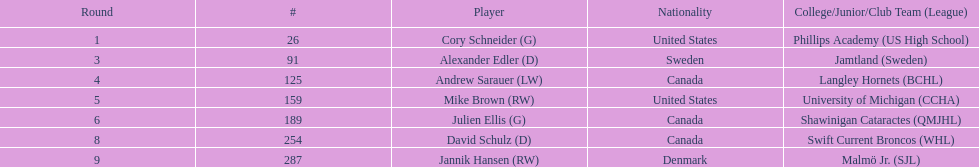Can you provide the names of the colleges and junior leagues where the players studied? Phillips Academy (US High School), Jamtland (Sweden), Langley Hornets (BCHL), University of Michigan (CCHA), Shawinigan Cataractes (QMJHL), Swift Current Broncos (WHL), Malmö Jr. (SJL). Additionally, identify the player who played for the langley hornets.? Andrew Sarauer (LW). 